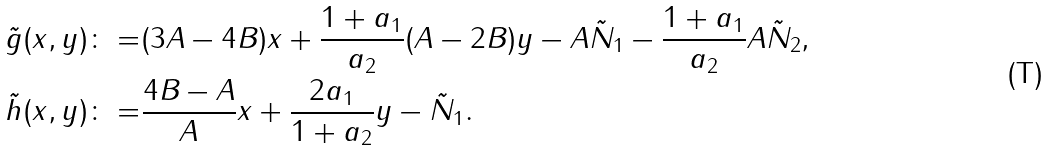Convert formula to latex. <formula><loc_0><loc_0><loc_500><loc_500>\tilde { g } ( x , y ) \colon = & ( 3 A - 4 B ) x + \frac { 1 + a _ { 1 } } { a _ { 2 } } ( A - 2 B ) y - A \tilde { N } _ { 1 } - \frac { 1 + a _ { 1 } } { a _ { 2 } } A \tilde { N } _ { 2 } , \\ \tilde { h } ( x , y ) \colon = & \frac { 4 B - A } { A } x + \frac { 2 a _ { 1 } } { 1 + a _ { 2 } } y - \tilde { N } _ { 1 } .</formula> 